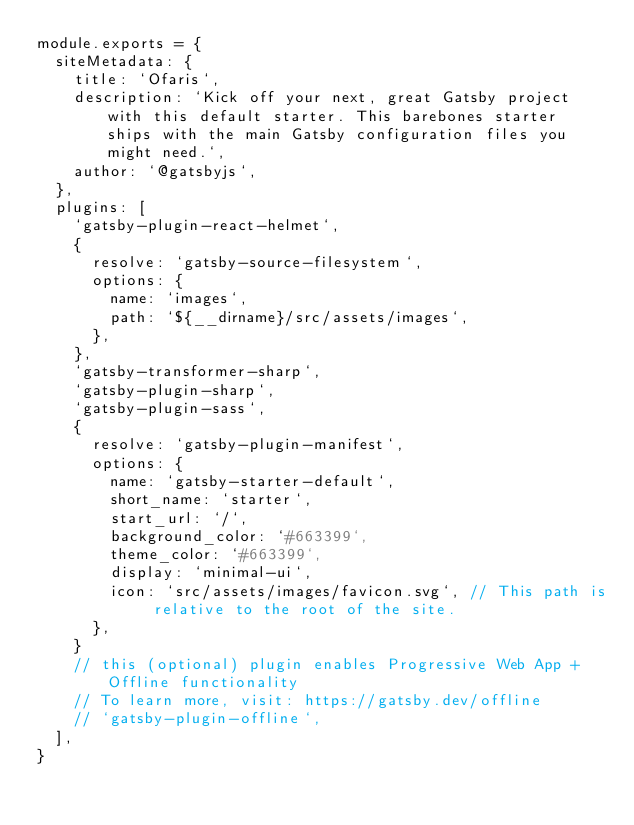Convert code to text. <code><loc_0><loc_0><loc_500><loc_500><_JavaScript_>module.exports = {
  siteMetadata: {
    title: `Ofaris`,
    description: `Kick off your next, great Gatsby project with this default starter. This barebones starter ships with the main Gatsby configuration files you might need.`,
    author: `@gatsbyjs`,
  },
  plugins: [
    `gatsby-plugin-react-helmet`,
    {
      resolve: `gatsby-source-filesystem`,
      options: {
        name: `images`,
        path: `${__dirname}/src/assets/images`,
      },
    },
    `gatsby-transformer-sharp`,
    `gatsby-plugin-sharp`,
    `gatsby-plugin-sass`,
    {
      resolve: `gatsby-plugin-manifest`,
      options: {
        name: `gatsby-starter-default`,
        short_name: `starter`,
        start_url: `/`,
        background_color: `#663399`,
        theme_color: `#663399`,
        display: `minimal-ui`,
        icon: `src/assets/images/favicon.svg`, // This path is relative to the root of the site.
      },
    }
    // this (optional) plugin enables Progressive Web App + Offline functionality
    // To learn more, visit: https://gatsby.dev/offline
    // `gatsby-plugin-offline`,
  ],
}
</code> 